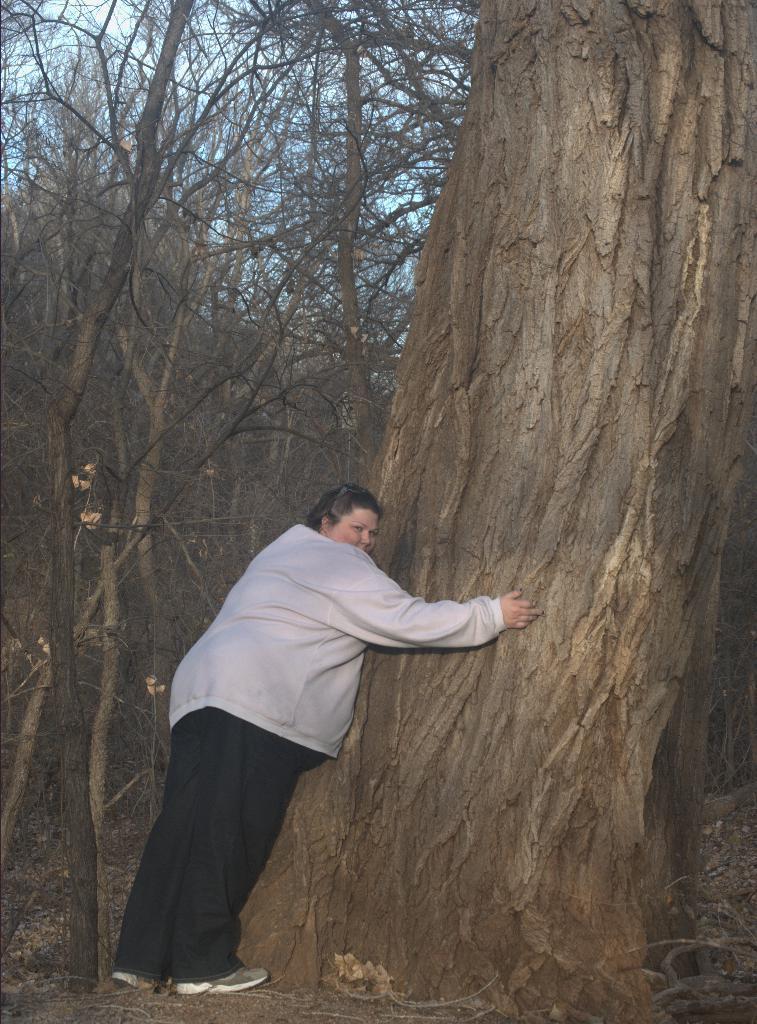Please provide a concise description of this image. In this image we can see a person standing near the tree. 